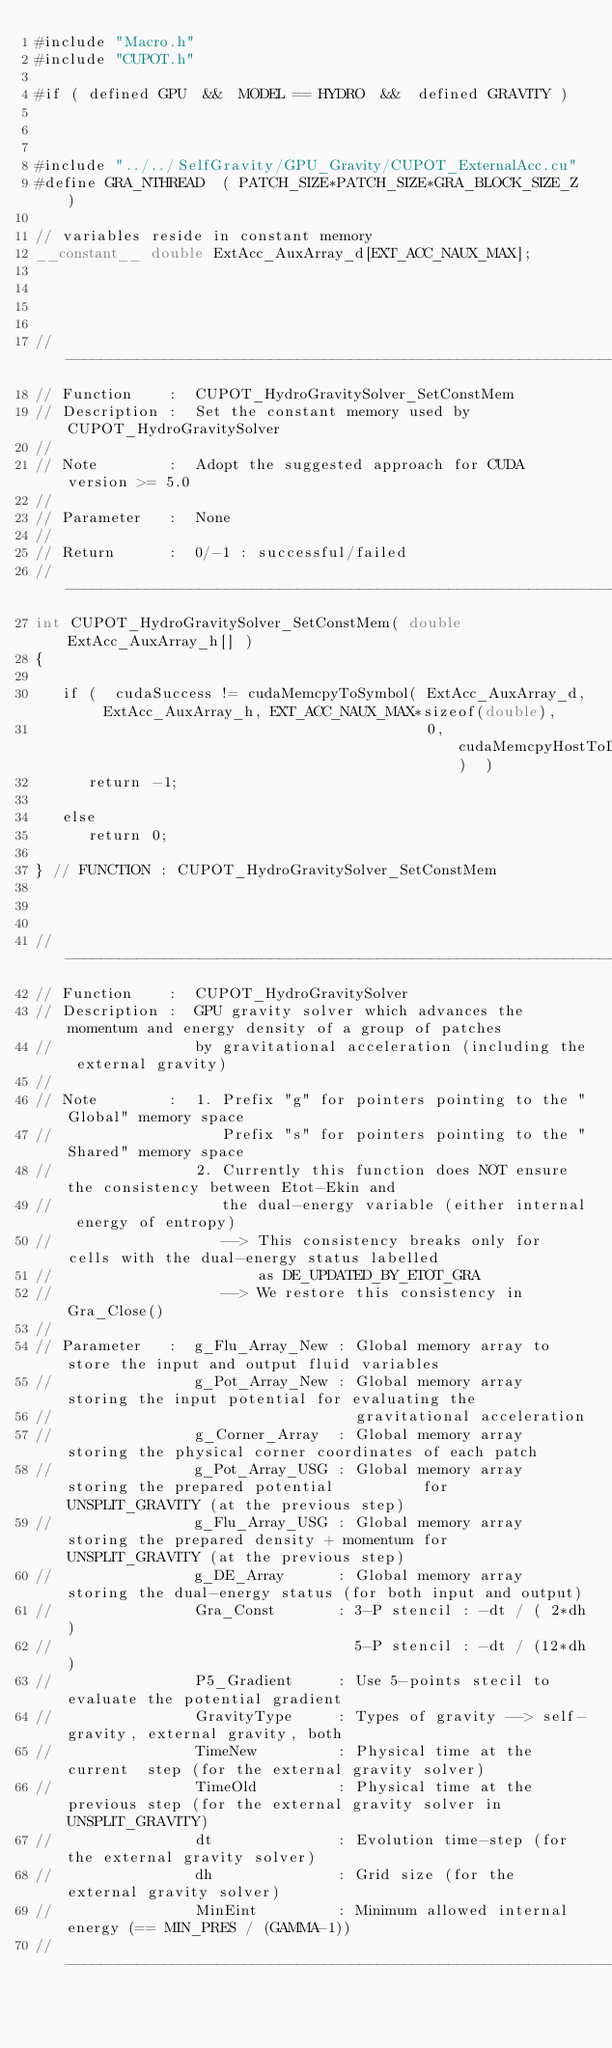<code> <loc_0><loc_0><loc_500><loc_500><_Cuda_>#include "Macro.h"
#include "CUPOT.h"

#if ( defined GPU  &&  MODEL == HYDRO  &&  defined GRAVITY )



#include "../../SelfGravity/GPU_Gravity/CUPOT_ExternalAcc.cu"
#define GRA_NTHREAD  ( PATCH_SIZE*PATCH_SIZE*GRA_BLOCK_SIZE_Z )

// variables reside in constant memory
__constant__ double ExtAcc_AuxArray_d[EXT_ACC_NAUX_MAX];




//-------------------------------------------------------------------------------------------------------
// Function    :  CUPOT_HydroGravitySolver_SetConstMem
// Description :  Set the constant memory used by CUPOT_HydroGravitySolver
//
// Note        :  Adopt the suggested approach for CUDA version >= 5.0
//
// Parameter   :  None
//
// Return      :  0/-1 : successful/failed
//---------------------------------------------------------------------------------------------------
int CUPOT_HydroGravitySolver_SetConstMem( double ExtAcc_AuxArray_h[] )
{

   if (  cudaSuccess != cudaMemcpyToSymbol( ExtAcc_AuxArray_d, ExtAcc_AuxArray_h, EXT_ACC_NAUX_MAX*sizeof(double),
                                            0, cudaMemcpyHostToDevice)  )
      return -1;

   else
      return 0;

} // FUNCTION : CUPOT_HydroGravitySolver_SetConstMem



//-------------------------------------------------------------------------------------------------------
// Function    :  CUPOT_HydroGravitySolver
// Description :  GPU gravity solver which advances the momentum and energy density of a group of patches
//                by gravitational acceleration (including the external gravity)
//
// Note        :  1. Prefix "g" for pointers pointing to the "Global" memory space
//                   Prefix "s" for pointers pointing to the "Shared" memory space
//                2. Currently this function does NOT ensure the consistency between Etot-Ekin and
//                   the dual-energy variable (either internal energy of entropy)
//                   --> This consistency breaks only for cells with the dual-energy status labelled
//                       as DE_UPDATED_BY_ETOT_GRA
//                   --> We restore this consistency in Gra_Close()
//
// Parameter   :  g_Flu_Array_New : Global memory array to store the input and output fluid variables
//                g_Pot_Array_New : Global memory array storing the input potential for evaluating the
//                                  gravitational acceleration
//                g_Corner_Array  : Global memory array storing the physical corner coordinates of each patch
//                g_Pot_Array_USG : Global memory array storing the prepared potential          for UNSPLIT_GRAVITY (at the previous step)
//                g_Flu_Array_USG : Global memory array storing the prepared density + momentum for UNSPLIT_GRAVITY (at the previous step)
//                g_DE_Array      : Global memory array storing the dual-energy status (for both input and output)
//                Gra_Const       : 3-P stencil : -dt / ( 2*dh)
//                                  5-P stencil : -dt / (12*dh)
//                P5_Gradient     : Use 5-points stecil to evaluate the potential gradient
//                GravityType     : Types of gravity --> self-gravity, external gravity, both
//                TimeNew         : Physical time at the current  step (for the external gravity solver)
//                TimeOld         : Physical time at the previous step (for the external gravity solver in UNSPLIT_GRAVITY)
//                dt              : Evolution time-step (for the external gravity solver)
//                dh              : Grid size (for the external gravity solver)
//                MinEint         : Minimum allowed internal energy (== MIN_PRES / (GAMMA-1))
//---------------------------------------------------------------------------------------------------</code> 